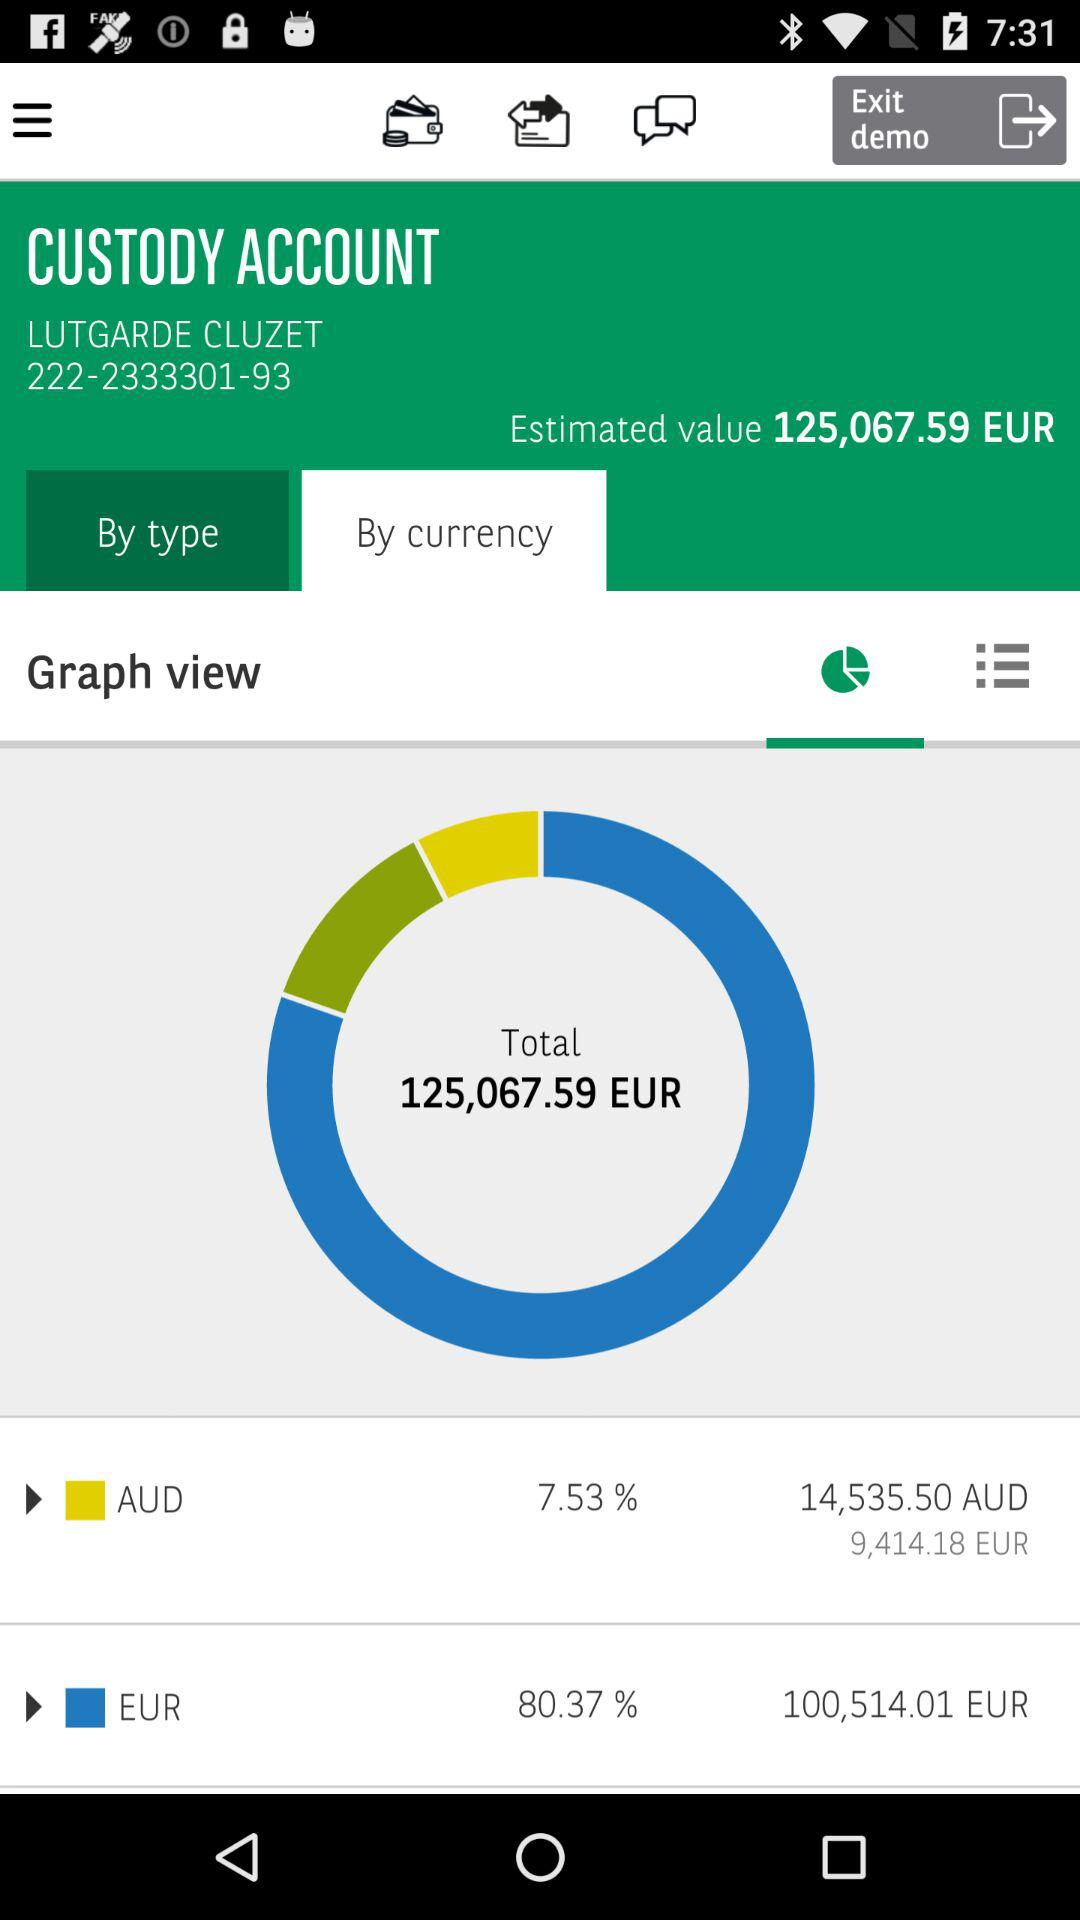What is the amount in AUD? The amount in AUD is 14,535.50. 